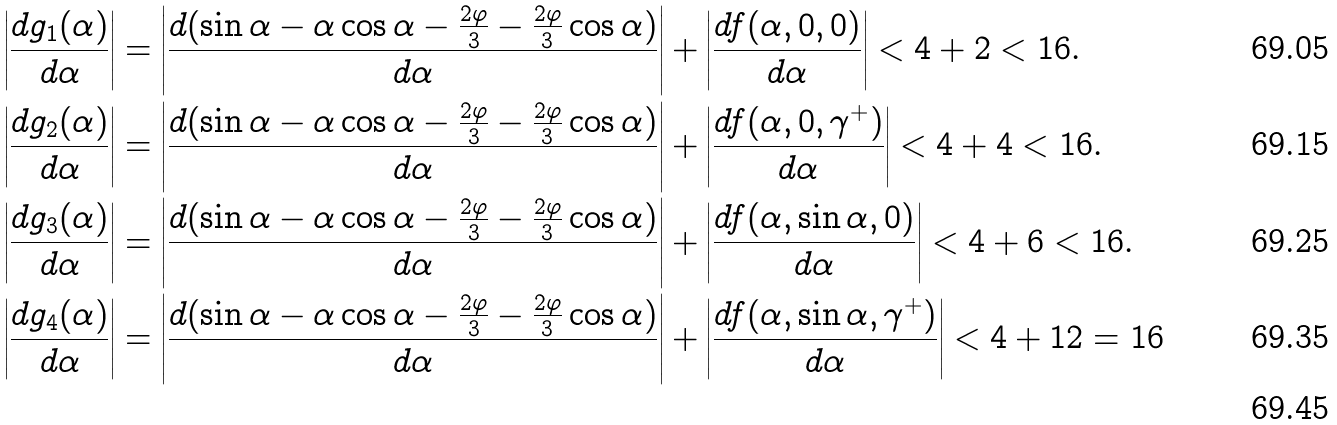<formula> <loc_0><loc_0><loc_500><loc_500>\left | \frac { d g _ { 1 } ( \alpha ) } { d \alpha } \right | & = \left | \frac { d ( \sin \alpha - \alpha \cos \alpha - \frac { 2 \varphi } { 3 } - \frac { 2 \varphi } { 3 } \cos \alpha ) } { d \alpha } \right | + \left | \frac { d f ( \alpha , 0 , 0 ) } { d \alpha } \right | < 4 + 2 < 1 6 . \\ \left | \frac { d g _ { 2 } ( \alpha ) } { d \alpha } \right | & = \left | \frac { d ( \sin \alpha - \alpha \cos \alpha - \frac { 2 \varphi } { 3 } - \frac { 2 \varphi } { 3 } \cos \alpha ) } { d \alpha } \right | + \left | \frac { d f ( \alpha , 0 , \gamma ^ { + } ) } { d \alpha } \right | < 4 + 4 < 1 6 . \\ \left | \frac { d g _ { 3 } ( \alpha ) } { d \alpha } \right | & = \left | \frac { d ( \sin \alpha - \alpha \cos \alpha - \frac { 2 \varphi } { 3 } - \frac { 2 \varphi } { 3 } \cos \alpha ) } { d \alpha } \right | + \left | \frac { d f ( \alpha , \sin \alpha , 0 ) } { d \alpha } \right | < 4 + 6 < 1 6 . \\ \left | \frac { d g _ { 4 } ( \alpha ) } { d \alpha } \right | & = \left | \frac { d ( \sin \alpha - \alpha \cos \alpha - \frac { 2 \varphi } { 3 } - \frac { 2 \varphi } { 3 } \cos \alpha ) } { d \alpha } \right | + \left | \frac { d f ( \alpha , \sin \alpha , \gamma ^ { + } ) } { d \alpha } \right | < 4 + 1 2 = 1 6 \\</formula> 